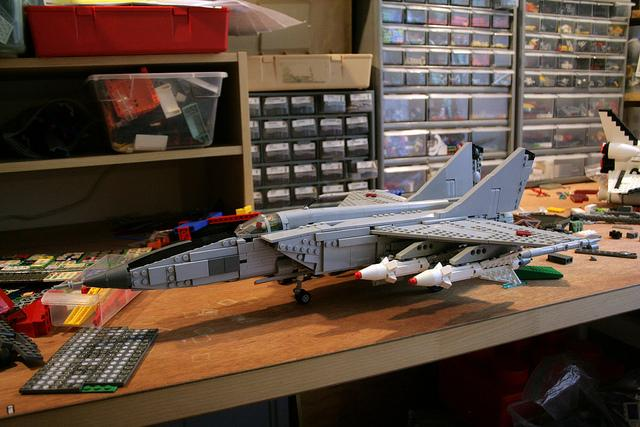What was used to build this plane? legos 